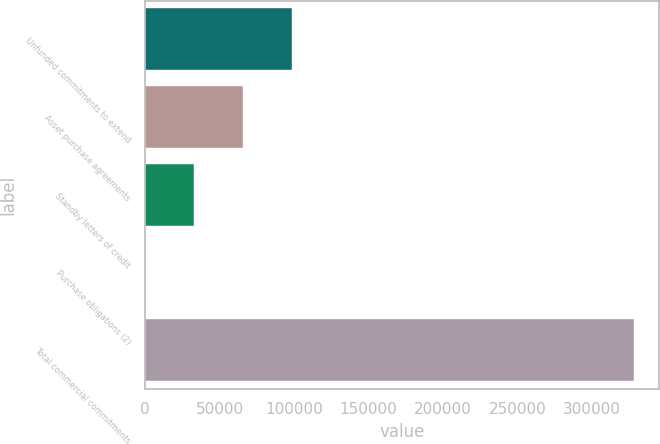<chart> <loc_0><loc_0><loc_500><loc_500><bar_chart><fcel>Unfunded commitments to extend<fcel>Asset purchase agreements<fcel>Standby letters of credit<fcel>Purchase obligations (2)<fcel>Total commercial commitments<nl><fcel>98614.3<fcel>65781.2<fcel>32948.1<fcel>115<fcel>328446<nl></chart> 